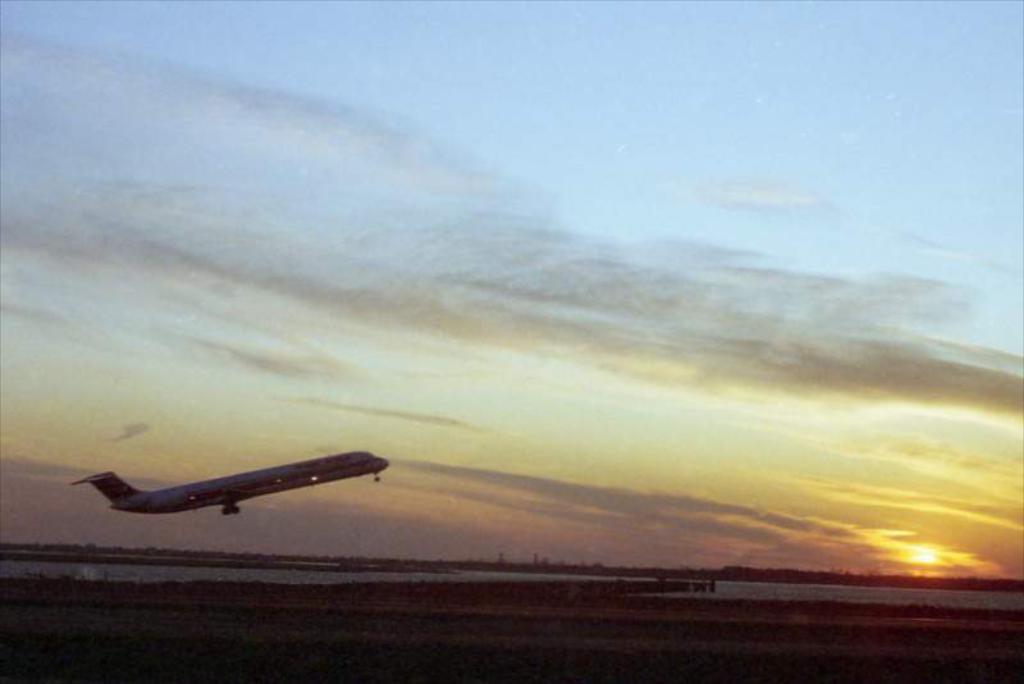Can you describe this image briefly? In this image we can see a flight is taking off, a sunset and a river, also we can see the sky. 